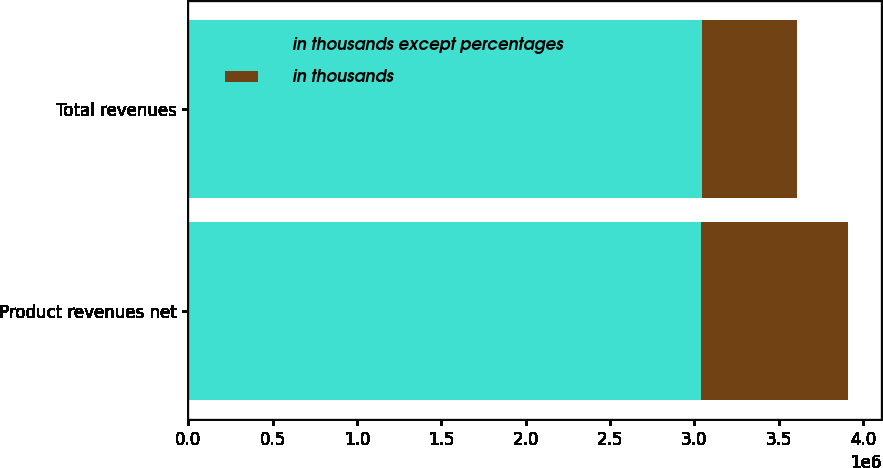Convert chart to OTSL. <chart><loc_0><loc_0><loc_500><loc_500><stacked_bar_chart><ecel><fcel>Product revenues net<fcel>Total revenues<nl><fcel>in thousands except percentages<fcel>3.03832e+06<fcel>3.0476e+06<nl><fcel>in thousands<fcel>872845<fcel>558945<nl></chart> 